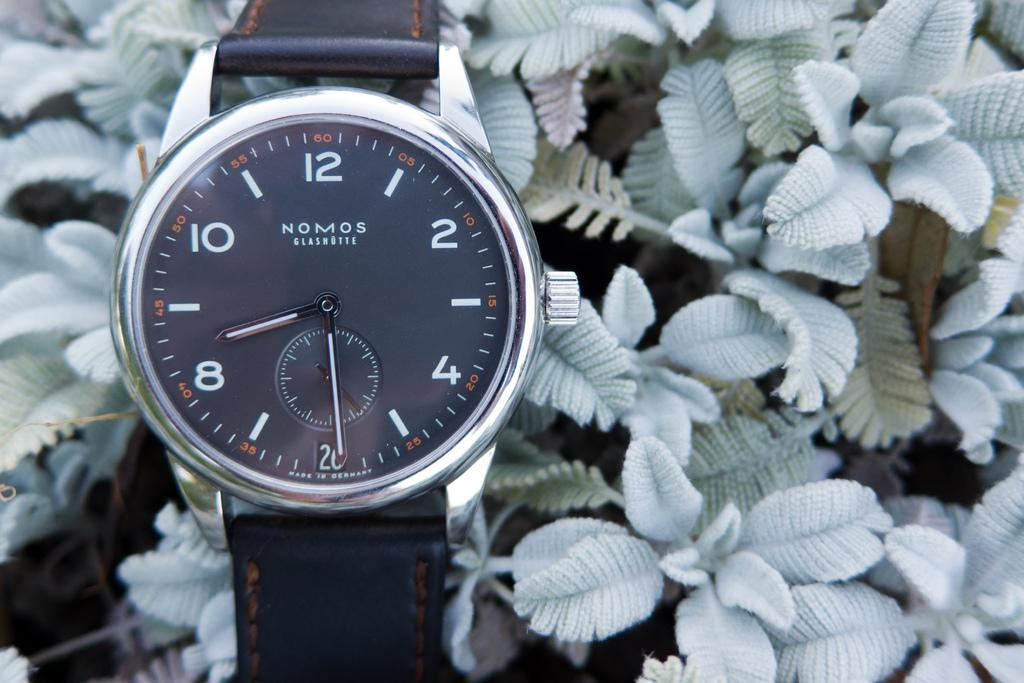<image>
Offer a succinct explanation of the picture presented. A Nomos watch sits atop some plant leaves. 